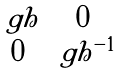<formula> <loc_0><loc_0><loc_500><loc_500>\begin{smallmatrix} \ g h & 0 \\ 0 & \ g h ^ { - 1 } \end{smallmatrix}</formula> 